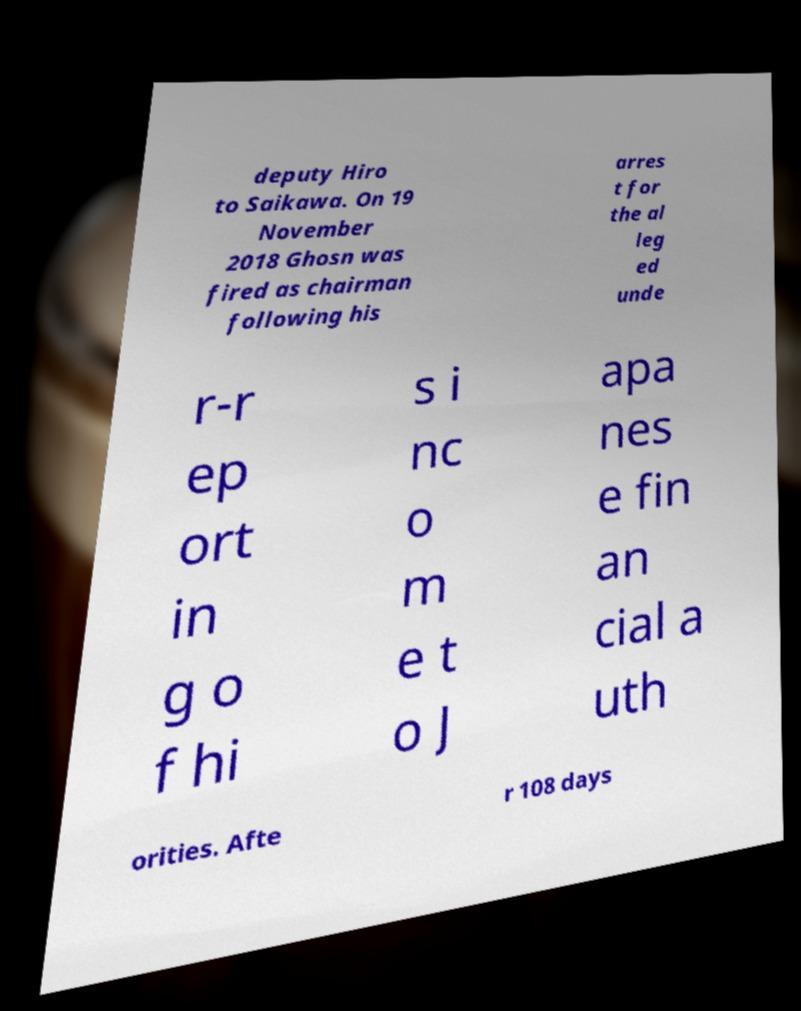I need the written content from this picture converted into text. Can you do that? deputy Hiro to Saikawa. On 19 November 2018 Ghosn was fired as chairman following his arres t for the al leg ed unde r-r ep ort in g o f hi s i nc o m e t o J apa nes e fin an cial a uth orities. Afte r 108 days 